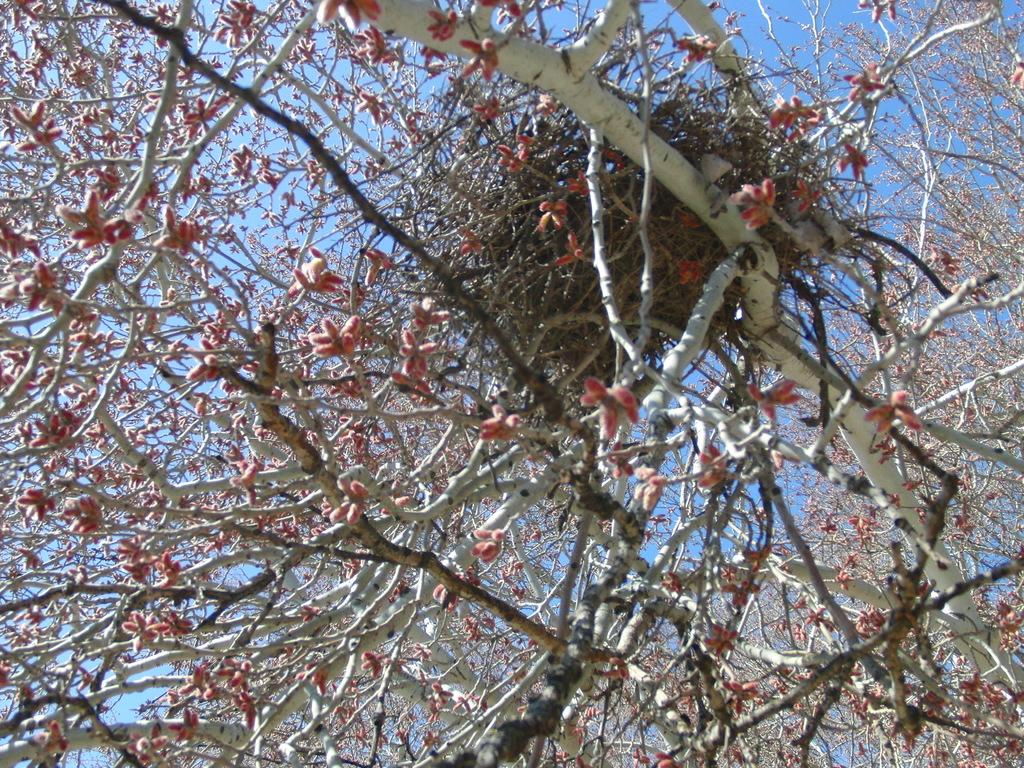What type of vegetation can be seen in the image? There are trees in the image. What part of the natural environment is visible in the image? The sky is visible in the background of the image. How many giants can be seen using the station in the image? There are no giants or stations present in the image. 